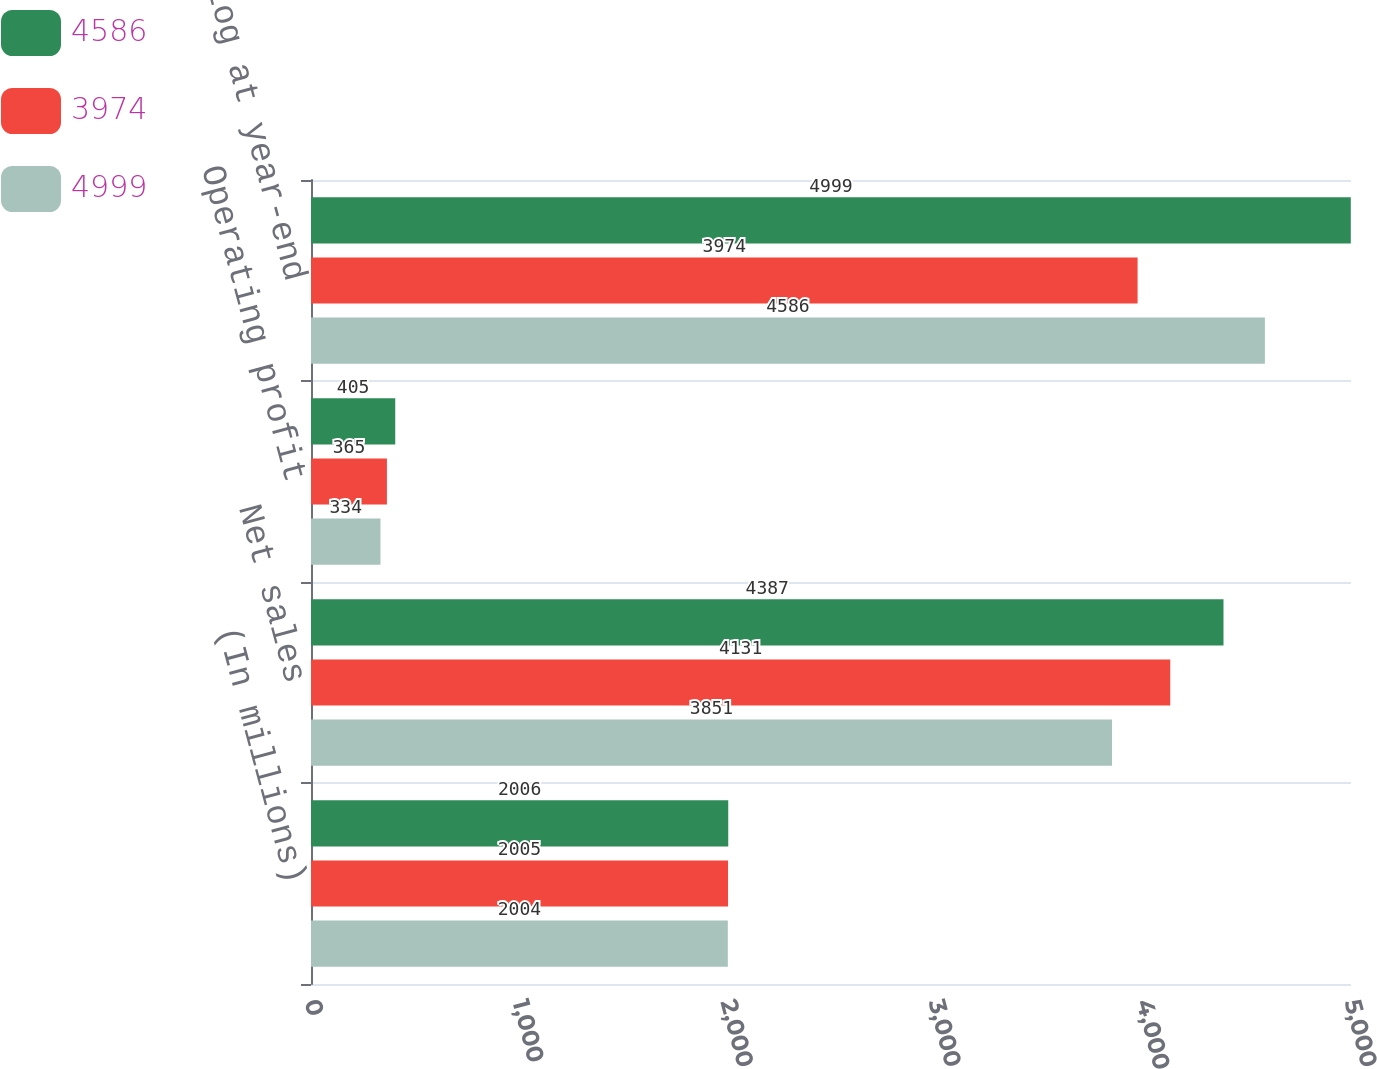<chart> <loc_0><loc_0><loc_500><loc_500><stacked_bar_chart><ecel><fcel>(In millions)<fcel>Net sales<fcel>Operating profit<fcel>Backlog at year-end<nl><fcel>4586<fcel>2006<fcel>4387<fcel>405<fcel>4999<nl><fcel>3974<fcel>2005<fcel>4131<fcel>365<fcel>3974<nl><fcel>4999<fcel>2004<fcel>3851<fcel>334<fcel>4586<nl></chart> 